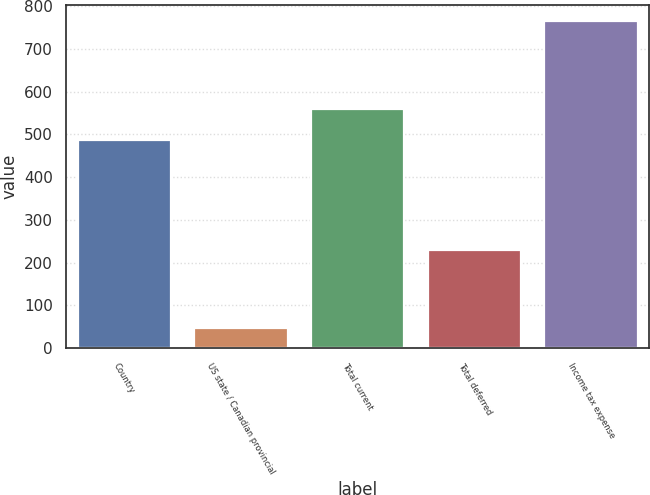Convert chart. <chart><loc_0><loc_0><loc_500><loc_500><bar_chart><fcel>Country<fcel>US state / Canadian provincial<fcel>Total current<fcel>Total deferred<fcel>Income tax expense<nl><fcel>488<fcel>47<fcel>559.8<fcel>230<fcel>765<nl></chart> 